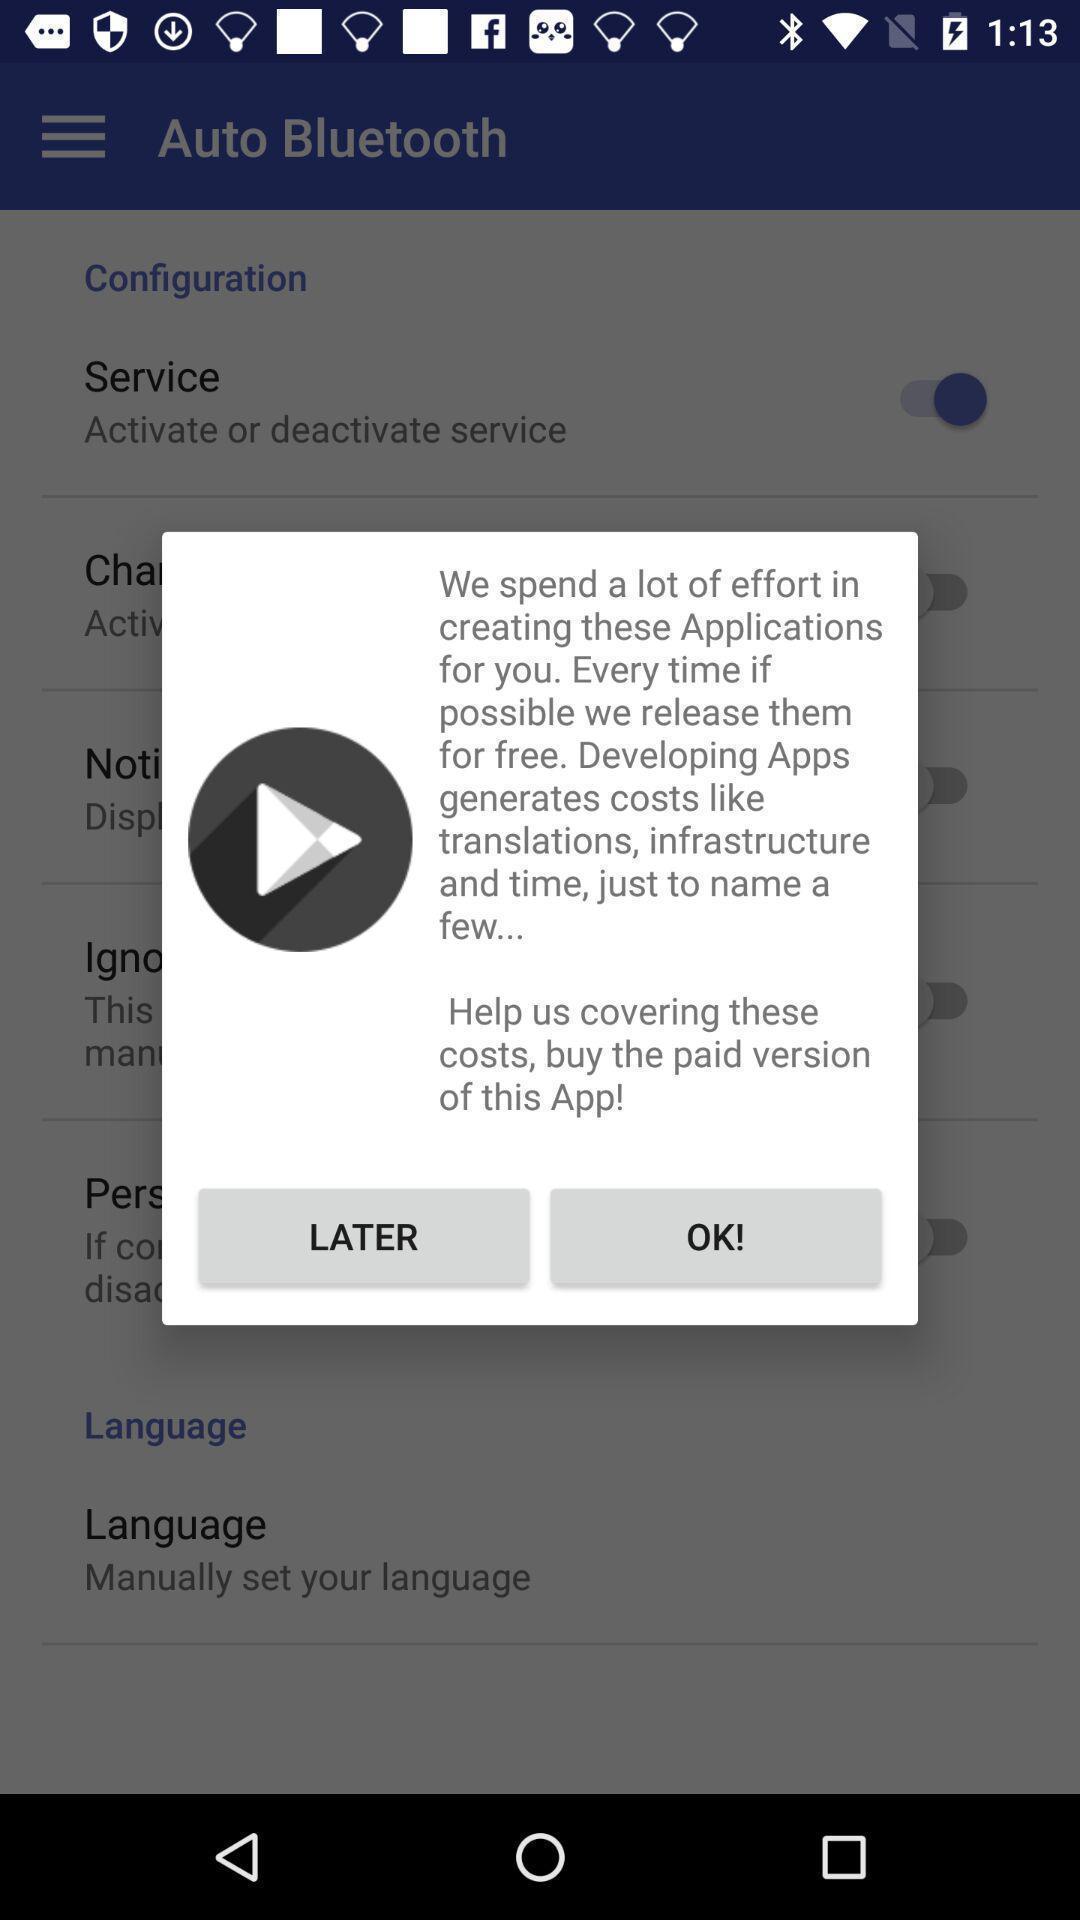Provide a detailed account of this screenshot. Pop-up showing a message to buy the paid version. 